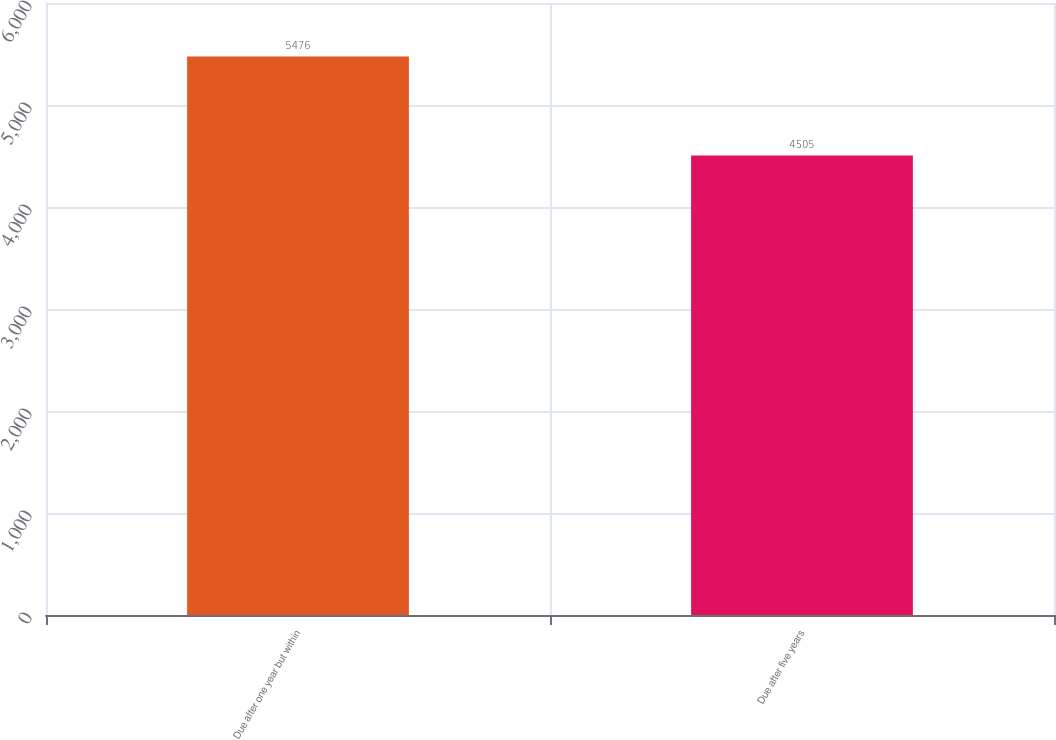Convert chart to OTSL. <chart><loc_0><loc_0><loc_500><loc_500><bar_chart><fcel>Due after one year but within<fcel>Due after five years<nl><fcel>5476<fcel>4505<nl></chart> 